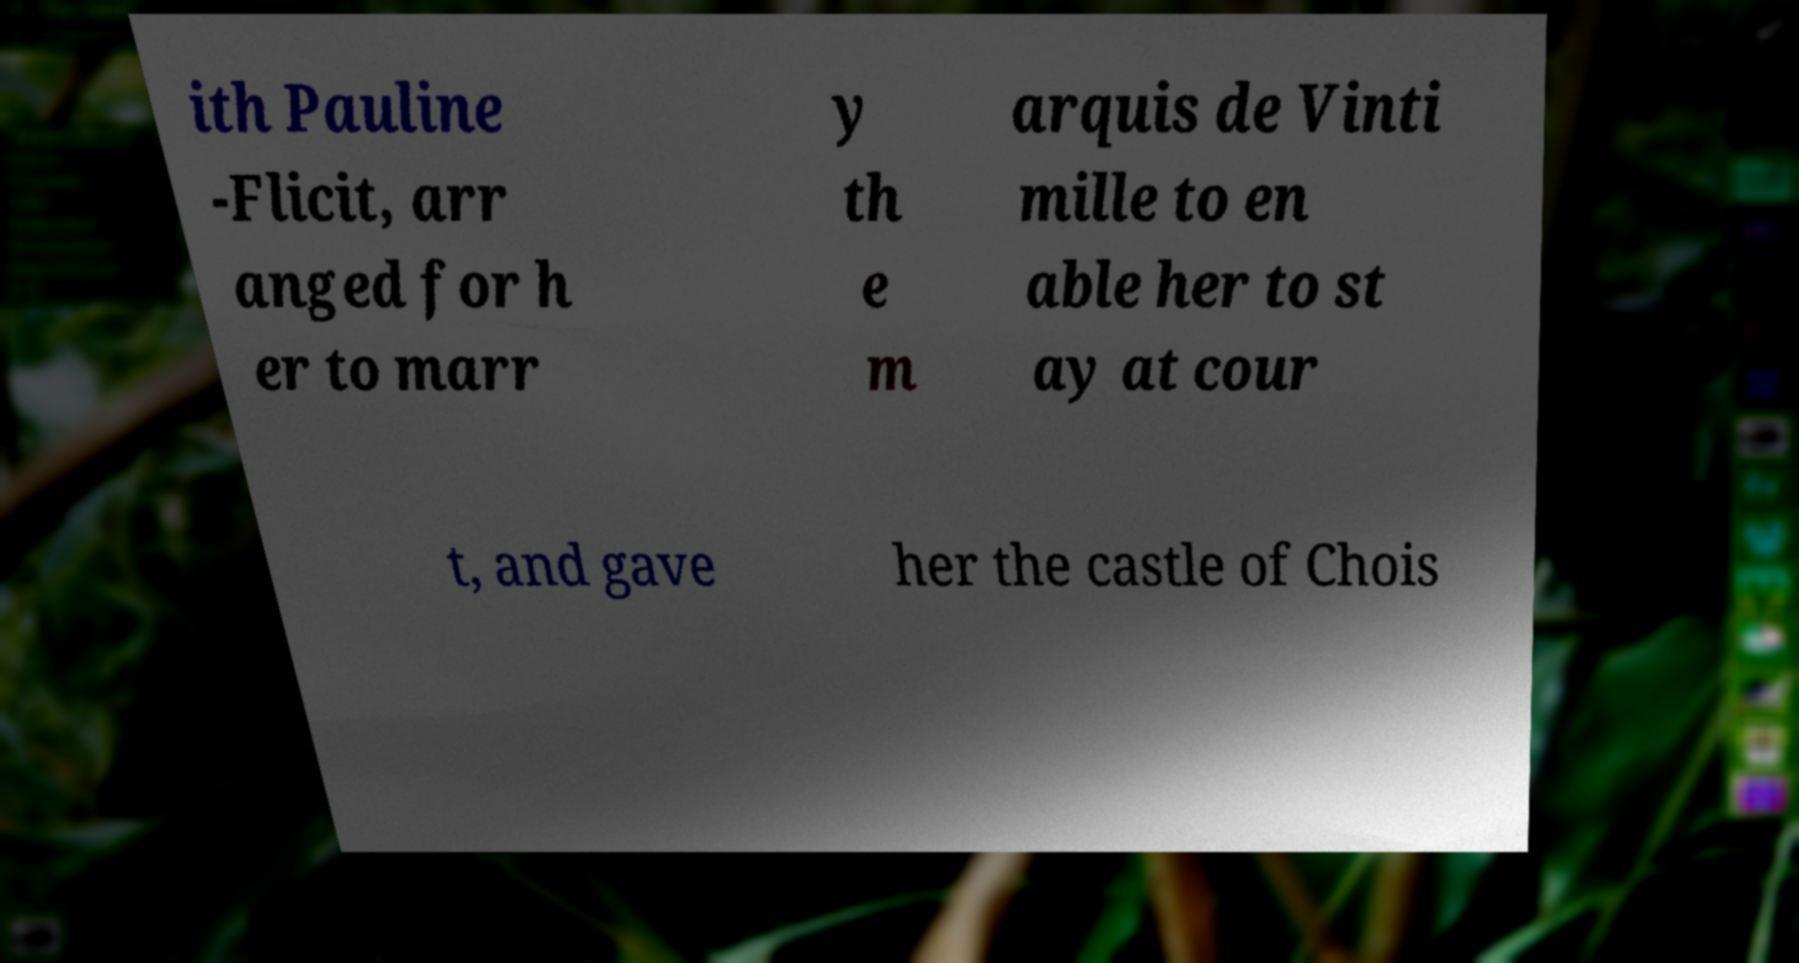I need the written content from this picture converted into text. Can you do that? ith Pauline -Flicit, arr anged for h er to marr y th e m arquis de Vinti mille to en able her to st ay at cour t, and gave her the castle of Chois 